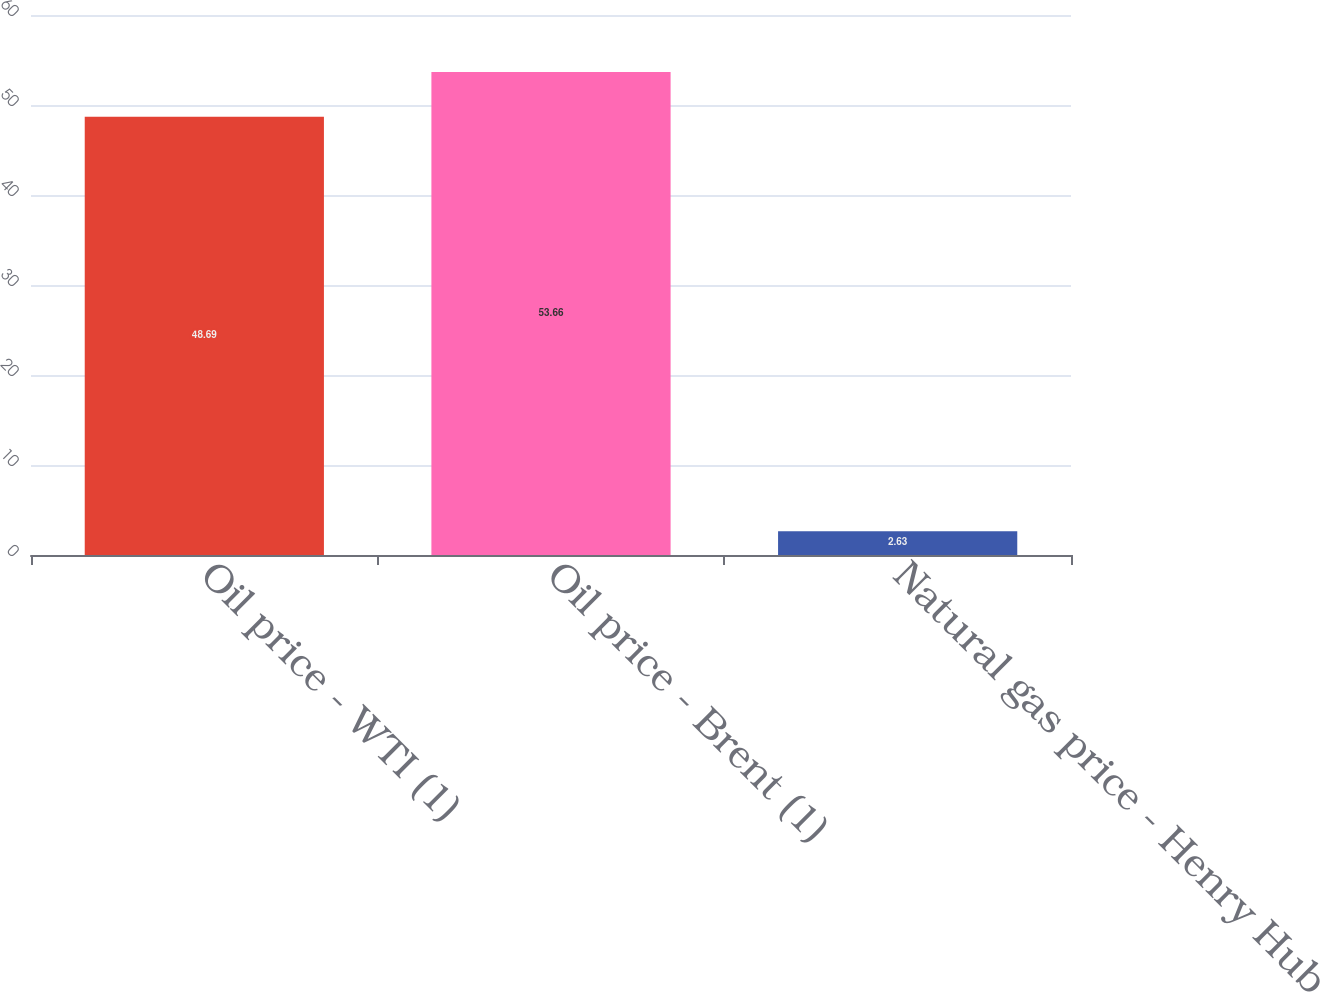Convert chart. <chart><loc_0><loc_0><loc_500><loc_500><bar_chart><fcel>Oil price - WTI (1)<fcel>Oil price - Brent (1)<fcel>Natural gas price - Henry Hub<nl><fcel>48.69<fcel>53.66<fcel>2.63<nl></chart> 